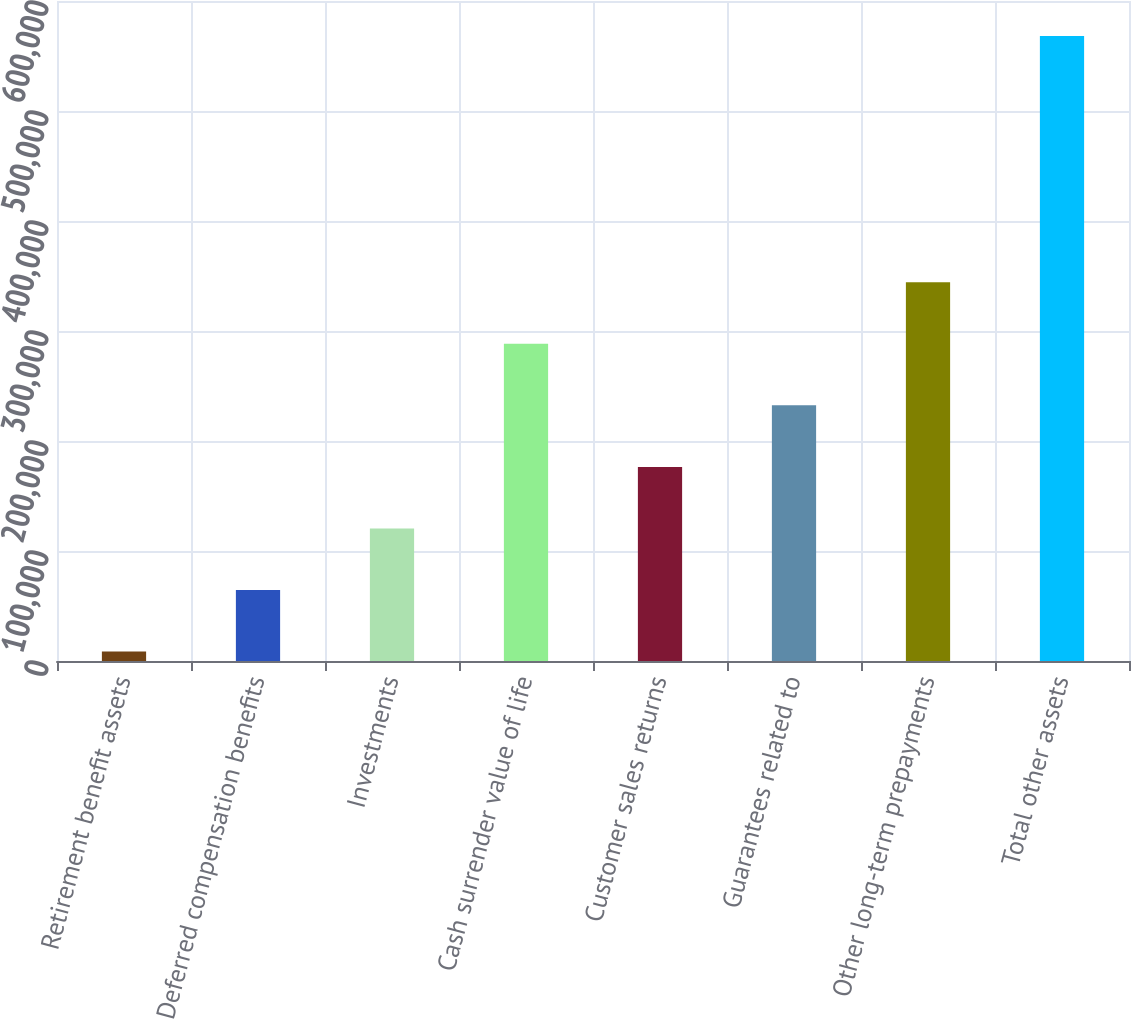<chart> <loc_0><loc_0><loc_500><loc_500><bar_chart><fcel>Retirement benefit assets<fcel>Deferred compensation benefits<fcel>Investments<fcel>Cash surrender value of life<fcel>Customer sales returns<fcel>Guarantees related to<fcel>Other long-term prepayments<fcel>Total other assets<nl><fcel>8573<fcel>64540.5<fcel>120508<fcel>288410<fcel>176476<fcel>232443<fcel>344378<fcel>568248<nl></chart> 